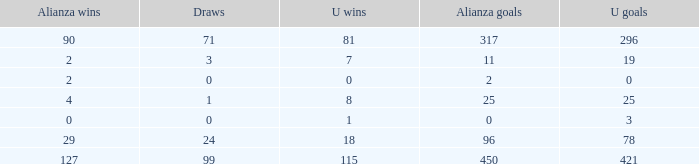What is the total number of U Wins, when Alianza Goals is "0", and when U Goals is greater than 3? 0.0. 